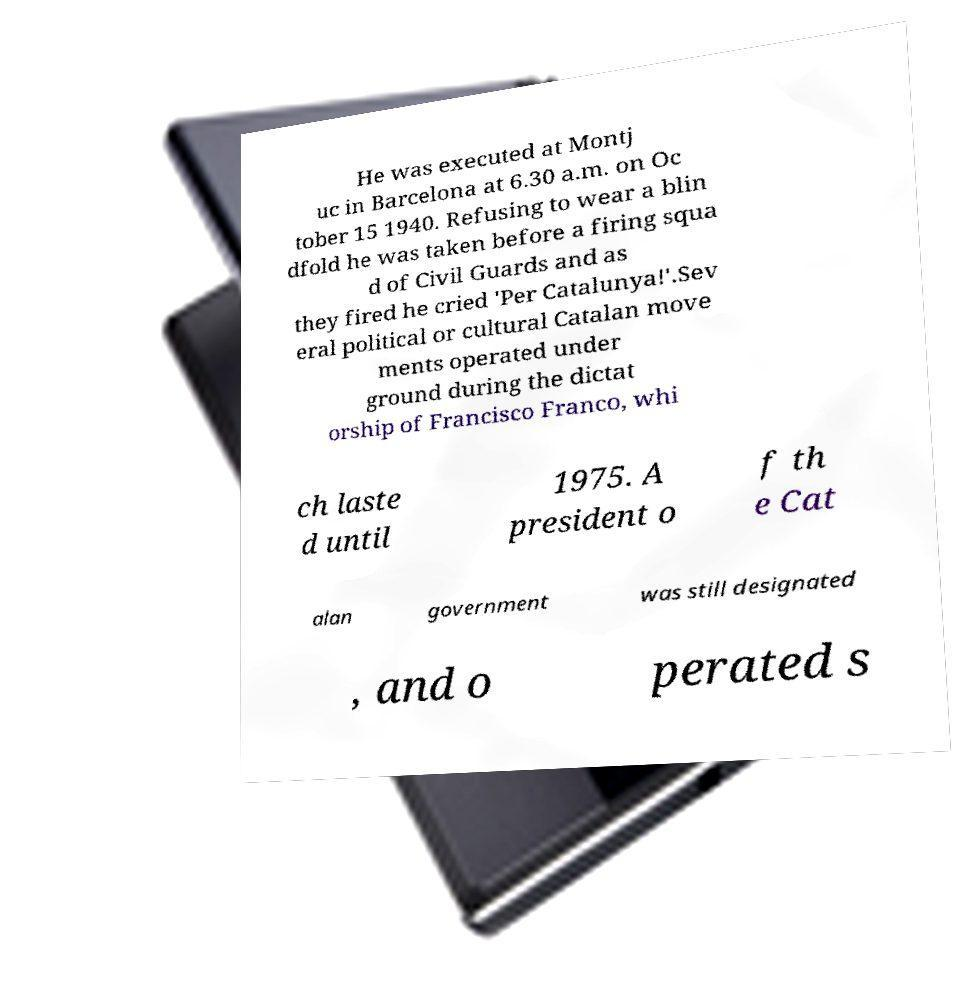What messages or text are displayed in this image? I need them in a readable, typed format. He was executed at Montj uc in Barcelona at 6.30 a.m. on Oc tober 15 1940. Refusing to wear a blin dfold he was taken before a firing squa d of Civil Guards and as they fired he cried 'Per Catalunya!'.Sev eral political or cultural Catalan move ments operated under ground during the dictat orship of Francisco Franco, whi ch laste d until 1975. A president o f th e Cat alan government was still designated , and o perated s 